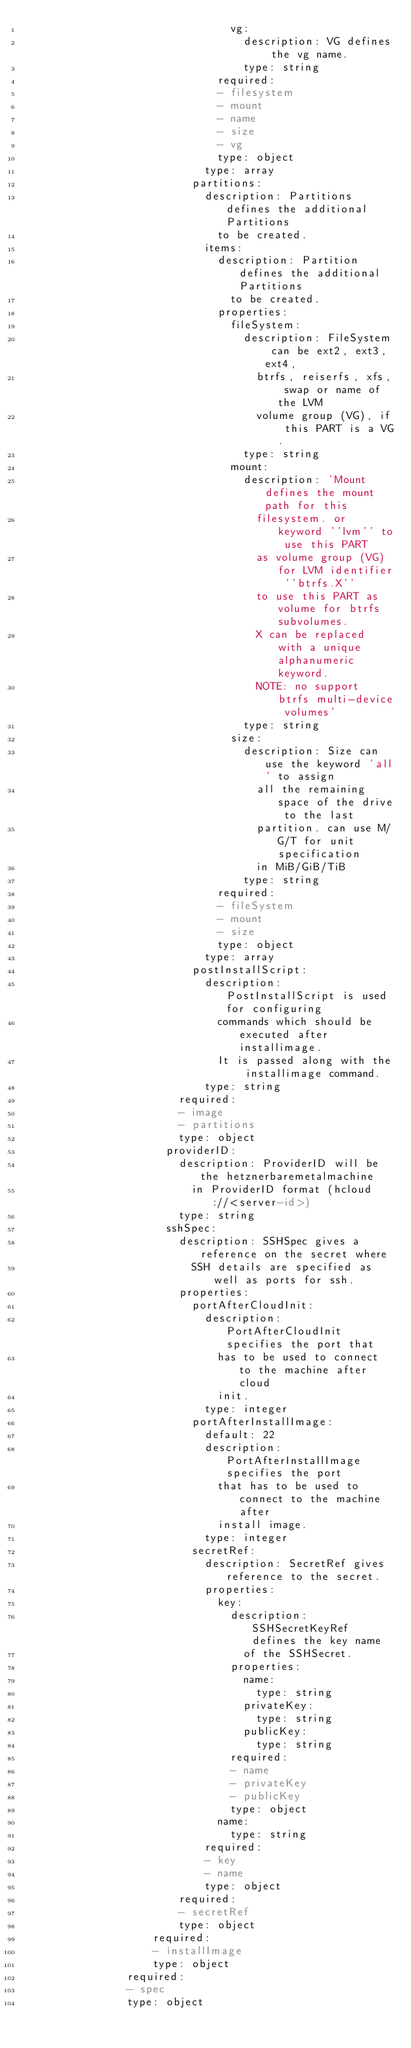Convert code to text. <code><loc_0><loc_0><loc_500><loc_500><_YAML_>                                vg:
                                  description: VG defines the vg name.
                                  type: string
                              required:
                              - filesystem
                              - mount
                              - name
                              - size
                              - vg
                              type: object
                            type: array
                          partitions:
                            description: Partitions defines the additional Partitions
                              to be created.
                            items:
                              description: Partition defines the additional Partitions
                                to be created.
                              properties:
                                fileSystem:
                                  description: FileSystem can be ext2, ext3, ext4,
                                    btrfs, reiserfs, xfs, swap or name of the LVM
                                    volume group (VG), if this PART is a VG.
                                  type: string
                                mount:
                                  description: 'Mount defines the mount path for this
                                    filesystem. or keyword ''lvm'' to use this PART
                                    as volume group (VG) for LVM identifier ''btrfs.X''
                                    to use this PART as volume for btrfs subvolumes.
                                    X can be replaced with a unique alphanumeric keyword.
                                    NOTE: no support btrfs multi-device volumes'
                                  type: string
                                size:
                                  description: Size can use the keyword 'all' to assign
                                    all the remaining space of the drive to the last
                                    partition. can use M/G/T for unit specification
                                    in MiB/GiB/TiB
                                  type: string
                              required:
                              - fileSystem
                              - mount
                              - size
                              type: object
                            type: array
                          postInstallScript:
                            description: PostInstallScript is used for configuring
                              commands which should be executed after installimage.
                              It is passed along with the installimage command.
                            type: string
                        required:
                        - image
                        - partitions
                        type: object
                      providerID:
                        description: ProviderID will be the hetznerbaremetalmachine
                          in ProviderID format (hcloud://<server-id>)
                        type: string
                      sshSpec:
                        description: SSHSpec gives a reference on the secret where
                          SSH details are specified as well as ports for ssh.
                        properties:
                          portAfterCloudInit:
                            description: PortAfterCloudInit specifies the port that
                              has to be used to connect to the machine after cloud
                              init.
                            type: integer
                          portAfterInstallImage:
                            default: 22
                            description: PortAfterInstallImage specifies the port
                              that has to be used to connect to the machine after
                              install image.
                            type: integer
                          secretRef:
                            description: SecretRef gives reference to the secret.
                            properties:
                              key:
                                description: SSHSecretKeyRef defines the key name
                                  of the SSHSecret.
                                properties:
                                  name:
                                    type: string
                                  privateKey:
                                    type: string
                                  publicKey:
                                    type: string
                                required:
                                - name
                                - privateKey
                                - publicKey
                                type: object
                              name:
                                type: string
                            required:
                            - key
                            - name
                            type: object
                        required:
                        - secretRef
                        type: object
                    required:
                    - installImage
                    type: object
                required:
                - spec
                type: object</code> 